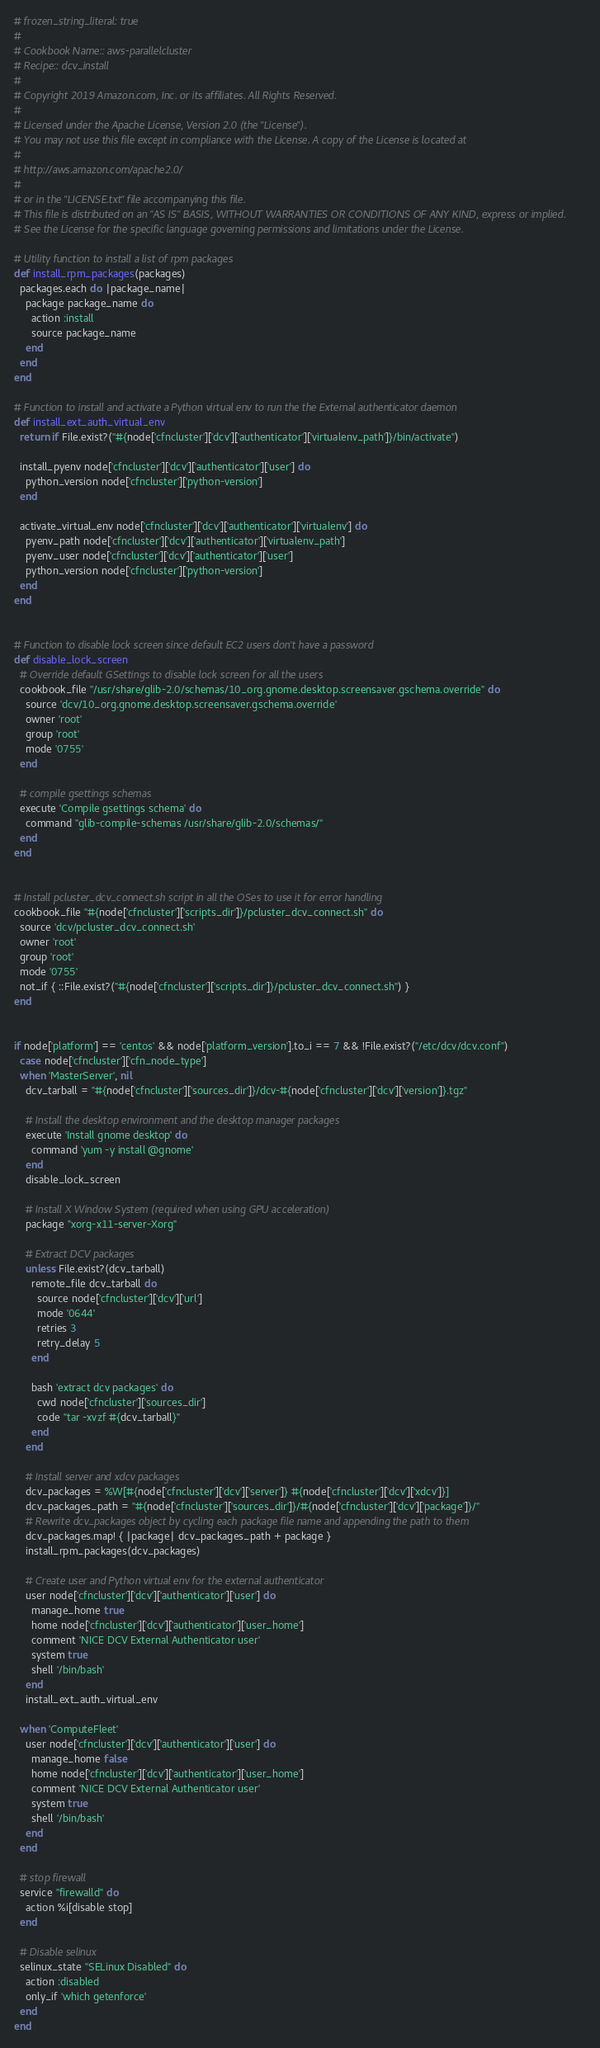<code> <loc_0><loc_0><loc_500><loc_500><_Ruby_># frozen_string_literal: true
#
# Cookbook Name:: aws-parallelcluster
# Recipe:: dcv_install
#
# Copyright 2019 Amazon.com, Inc. or its affiliates. All Rights Reserved.
#
# Licensed under the Apache License, Version 2.0 (the "License").
# You may not use this file except in compliance with the License. A copy of the License is located at
#
# http://aws.amazon.com/apache2.0/
#
# or in the "LICENSE.txt" file accompanying this file.
# This file is distributed on an "AS IS" BASIS, WITHOUT WARRANTIES OR CONDITIONS OF ANY KIND, express or implied.
# See the License for the specific language governing permissions and limitations under the License.

# Utility function to install a list of rpm packages
def install_rpm_packages(packages)
  packages.each do |package_name|
    package package_name do
      action :install
      source package_name
    end
  end
end

# Function to install and activate a Python virtual env to run the the External authenticator daemon
def install_ext_auth_virtual_env
  return if File.exist?("#{node['cfncluster']['dcv']['authenticator']['virtualenv_path']}/bin/activate")

  install_pyenv node['cfncluster']['dcv']['authenticator']['user'] do
    python_version node['cfncluster']['python-version']
  end

  activate_virtual_env node['cfncluster']['dcv']['authenticator']['virtualenv'] do
    pyenv_path node['cfncluster']['dcv']['authenticator']['virtualenv_path']
    pyenv_user node['cfncluster']['dcv']['authenticator']['user']
    python_version node['cfncluster']['python-version']
  end
end


# Function to disable lock screen since default EC2 users don't have a password
def disable_lock_screen
  # Override default GSettings to disable lock screen for all the users
  cookbook_file "/usr/share/glib-2.0/schemas/10_org.gnome.desktop.screensaver.gschema.override" do
    source 'dcv/10_org.gnome.desktop.screensaver.gschema.override'
    owner 'root'
    group 'root'
    mode '0755'
  end

  # compile gsettings schemas
  execute 'Compile gsettings schema' do
    command "glib-compile-schemas /usr/share/glib-2.0/schemas/"
  end
end


# Install pcluster_dcv_connect.sh script in all the OSes to use it for error handling
cookbook_file "#{node['cfncluster']['scripts_dir']}/pcluster_dcv_connect.sh" do
  source 'dcv/pcluster_dcv_connect.sh'
  owner 'root'
  group 'root'
  mode '0755'
  not_if { ::File.exist?("#{node['cfncluster']['scripts_dir']}/pcluster_dcv_connect.sh") }
end


if node['platform'] == 'centos' && node['platform_version'].to_i == 7 && !File.exist?("/etc/dcv/dcv.conf")
  case node['cfncluster']['cfn_node_type']
  when 'MasterServer', nil
    dcv_tarball = "#{node['cfncluster']['sources_dir']}/dcv-#{node['cfncluster']['dcv']['version']}.tgz"

    # Install the desktop environment and the desktop manager packages
    execute 'Install gnome desktop' do
      command 'yum -y install @gnome'
    end
    disable_lock_screen

    # Install X Window System (required when using GPU acceleration)
    package "xorg-x11-server-Xorg"

    # Extract DCV packages
    unless File.exist?(dcv_tarball)
      remote_file dcv_tarball do
        source node['cfncluster']['dcv']['url']
        mode '0644'
        retries 3
        retry_delay 5
      end

      bash 'extract dcv packages' do
        cwd node['cfncluster']['sources_dir']
        code "tar -xvzf #{dcv_tarball}"
      end
    end

    # Install server and xdcv packages
    dcv_packages = %W[#{node['cfncluster']['dcv']['server']} #{node['cfncluster']['dcv']['xdcv']}]
    dcv_packages_path = "#{node['cfncluster']['sources_dir']}/#{node['cfncluster']['dcv']['package']}/"
    # Rewrite dcv_packages object by cycling each package file name and appending the path to them
    dcv_packages.map! { |package| dcv_packages_path + package }
    install_rpm_packages(dcv_packages)

    # Create user and Python virtual env for the external authenticator
    user node['cfncluster']['dcv']['authenticator']['user'] do
      manage_home true
      home node['cfncluster']['dcv']['authenticator']['user_home']
      comment 'NICE DCV External Authenticator user'
      system true
      shell '/bin/bash'
    end
    install_ext_auth_virtual_env

  when 'ComputeFleet'
    user node['cfncluster']['dcv']['authenticator']['user'] do
      manage_home false
      home node['cfncluster']['dcv']['authenticator']['user_home']
      comment 'NICE DCV External Authenticator user'
      system true
      shell '/bin/bash'
    end
  end

  # stop firewall
  service "firewalld" do
    action %i[disable stop]
  end

  # Disable selinux
  selinux_state "SELinux Disabled" do
    action :disabled
    only_if 'which getenforce'
  end
end
</code> 